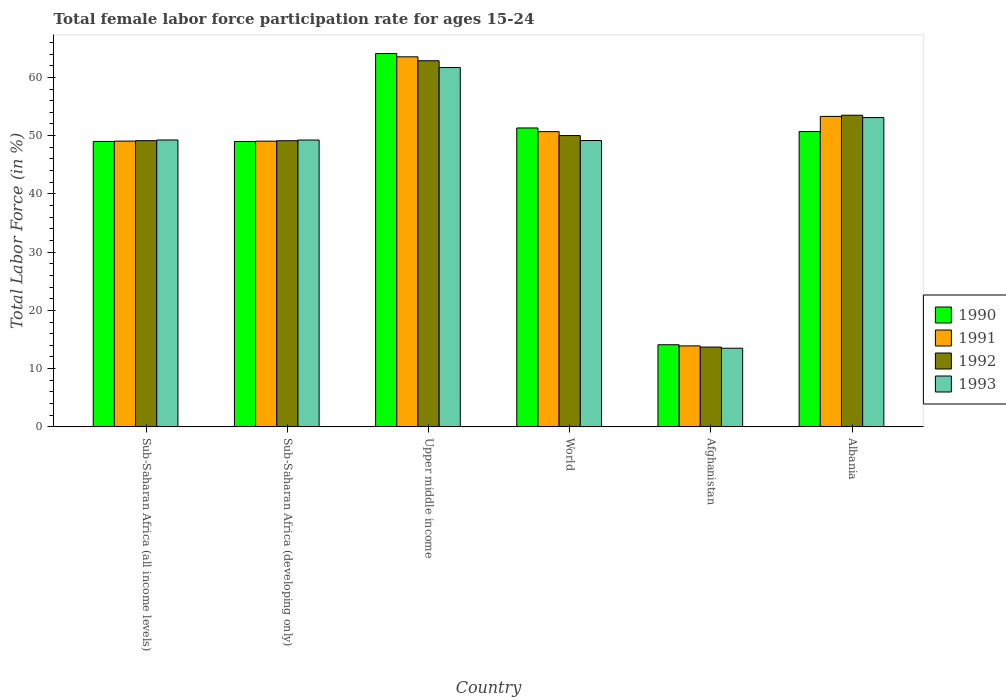How many groups of bars are there?
Provide a succinct answer. 6. Are the number of bars per tick equal to the number of legend labels?
Your answer should be very brief. Yes. How many bars are there on the 6th tick from the left?
Make the answer very short. 4. What is the label of the 6th group of bars from the left?
Your response must be concise. Albania. In how many cases, is the number of bars for a given country not equal to the number of legend labels?
Your answer should be very brief. 0. What is the female labor force participation rate in 1990 in World?
Offer a very short reply. 51.31. Across all countries, what is the maximum female labor force participation rate in 1991?
Offer a very short reply. 63.53. Across all countries, what is the minimum female labor force participation rate in 1992?
Offer a terse response. 13.7. In which country was the female labor force participation rate in 1991 maximum?
Offer a terse response. Upper middle income. In which country was the female labor force participation rate in 1993 minimum?
Make the answer very short. Afghanistan. What is the total female labor force participation rate in 1991 in the graph?
Give a very brief answer. 279.52. What is the difference between the female labor force participation rate in 1990 in Sub-Saharan Africa (developing only) and that in Upper middle income?
Give a very brief answer. -15.1. What is the difference between the female labor force participation rate in 1993 in Albania and the female labor force participation rate in 1990 in Afghanistan?
Ensure brevity in your answer.  39. What is the average female labor force participation rate in 1991 per country?
Offer a very short reply. 46.59. What is the difference between the female labor force participation rate of/in 1992 and female labor force participation rate of/in 1990 in Albania?
Ensure brevity in your answer.  2.8. In how many countries, is the female labor force participation rate in 1990 greater than 4 %?
Your answer should be very brief. 6. What is the ratio of the female labor force participation rate in 1993 in Afghanistan to that in Sub-Saharan Africa (all income levels)?
Keep it short and to the point. 0.27. Is the difference between the female labor force participation rate in 1992 in Afghanistan and Albania greater than the difference between the female labor force participation rate in 1990 in Afghanistan and Albania?
Your response must be concise. No. What is the difference between the highest and the second highest female labor force participation rate in 1992?
Provide a short and direct response. -3.49. What is the difference between the highest and the lowest female labor force participation rate in 1990?
Offer a terse response. 49.99. Is it the case that in every country, the sum of the female labor force participation rate in 1990 and female labor force participation rate in 1991 is greater than the sum of female labor force participation rate in 1993 and female labor force participation rate in 1992?
Make the answer very short. No. What does the 1st bar from the left in Afghanistan represents?
Offer a terse response. 1990. Is it the case that in every country, the sum of the female labor force participation rate in 1993 and female labor force participation rate in 1990 is greater than the female labor force participation rate in 1992?
Keep it short and to the point. Yes. How many bars are there?
Keep it short and to the point. 24. Are all the bars in the graph horizontal?
Offer a terse response. No. What is the difference between two consecutive major ticks on the Y-axis?
Provide a short and direct response. 10. Does the graph contain any zero values?
Keep it short and to the point. No. Does the graph contain grids?
Make the answer very short. No. Where does the legend appear in the graph?
Your answer should be very brief. Center right. How many legend labels are there?
Provide a succinct answer. 4. What is the title of the graph?
Offer a very short reply. Total female labor force participation rate for ages 15-24. What is the Total Labor Force (in %) of 1990 in Sub-Saharan Africa (all income levels)?
Ensure brevity in your answer.  49. What is the Total Labor Force (in %) of 1991 in Sub-Saharan Africa (all income levels)?
Keep it short and to the point. 49.06. What is the Total Labor Force (in %) of 1992 in Sub-Saharan Africa (all income levels)?
Provide a short and direct response. 49.13. What is the Total Labor Force (in %) in 1993 in Sub-Saharan Africa (all income levels)?
Offer a terse response. 49.25. What is the Total Labor Force (in %) of 1990 in Sub-Saharan Africa (developing only)?
Your answer should be compact. 48.99. What is the Total Labor Force (in %) of 1991 in Sub-Saharan Africa (developing only)?
Your answer should be compact. 49.05. What is the Total Labor Force (in %) in 1992 in Sub-Saharan Africa (developing only)?
Make the answer very short. 49.12. What is the Total Labor Force (in %) of 1993 in Sub-Saharan Africa (developing only)?
Make the answer very short. 49.24. What is the Total Labor Force (in %) in 1990 in Upper middle income?
Keep it short and to the point. 64.09. What is the Total Labor Force (in %) of 1991 in Upper middle income?
Provide a succinct answer. 63.53. What is the Total Labor Force (in %) of 1992 in Upper middle income?
Provide a succinct answer. 62.85. What is the Total Labor Force (in %) in 1993 in Upper middle income?
Give a very brief answer. 61.69. What is the Total Labor Force (in %) of 1990 in World?
Your answer should be compact. 51.31. What is the Total Labor Force (in %) in 1991 in World?
Give a very brief answer. 50.69. What is the Total Labor Force (in %) in 1992 in World?
Make the answer very short. 50.01. What is the Total Labor Force (in %) in 1993 in World?
Offer a very short reply. 49.16. What is the Total Labor Force (in %) in 1990 in Afghanistan?
Offer a very short reply. 14.1. What is the Total Labor Force (in %) in 1991 in Afghanistan?
Provide a succinct answer. 13.9. What is the Total Labor Force (in %) in 1992 in Afghanistan?
Give a very brief answer. 13.7. What is the Total Labor Force (in %) of 1993 in Afghanistan?
Your response must be concise. 13.5. What is the Total Labor Force (in %) of 1990 in Albania?
Your answer should be very brief. 50.7. What is the Total Labor Force (in %) in 1991 in Albania?
Offer a terse response. 53.3. What is the Total Labor Force (in %) of 1992 in Albania?
Your answer should be compact. 53.5. What is the Total Labor Force (in %) in 1993 in Albania?
Your answer should be compact. 53.1. Across all countries, what is the maximum Total Labor Force (in %) in 1990?
Offer a terse response. 64.09. Across all countries, what is the maximum Total Labor Force (in %) in 1991?
Provide a succinct answer. 63.53. Across all countries, what is the maximum Total Labor Force (in %) in 1992?
Your answer should be very brief. 62.85. Across all countries, what is the maximum Total Labor Force (in %) in 1993?
Provide a short and direct response. 61.69. Across all countries, what is the minimum Total Labor Force (in %) of 1990?
Offer a terse response. 14.1. Across all countries, what is the minimum Total Labor Force (in %) of 1991?
Provide a succinct answer. 13.9. Across all countries, what is the minimum Total Labor Force (in %) in 1992?
Your answer should be very brief. 13.7. What is the total Total Labor Force (in %) in 1990 in the graph?
Offer a very short reply. 278.2. What is the total Total Labor Force (in %) in 1991 in the graph?
Your answer should be very brief. 279.52. What is the total Total Labor Force (in %) in 1992 in the graph?
Your response must be concise. 278.31. What is the total Total Labor Force (in %) of 1993 in the graph?
Provide a succinct answer. 275.95. What is the difference between the Total Labor Force (in %) of 1990 in Sub-Saharan Africa (all income levels) and that in Sub-Saharan Africa (developing only)?
Your answer should be very brief. 0.01. What is the difference between the Total Labor Force (in %) in 1991 in Sub-Saharan Africa (all income levels) and that in Sub-Saharan Africa (developing only)?
Offer a very short reply. 0.01. What is the difference between the Total Labor Force (in %) of 1992 in Sub-Saharan Africa (all income levels) and that in Sub-Saharan Africa (developing only)?
Keep it short and to the point. 0.01. What is the difference between the Total Labor Force (in %) of 1993 in Sub-Saharan Africa (all income levels) and that in Sub-Saharan Africa (developing only)?
Provide a short and direct response. 0.01. What is the difference between the Total Labor Force (in %) of 1990 in Sub-Saharan Africa (all income levels) and that in Upper middle income?
Your response must be concise. -15.09. What is the difference between the Total Labor Force (in %) in 1991 in Sub-Saharan Africa (all income levels) and that in Upper middle income?
Give a very brief answer. -14.47. What is the difference between the Total Labor Force (in %) of 1992 in Sub-Saharan Africa (all income levels) and that in Upper middle income?
Offer a terse response. -13.72. What is the difference between the Total Labor Force (in %) in 1993 in Sub-Saharan Africa (all income levels) and that in Upper middle income?
Offer a very short reply. -12.44. What is the difference between the Total Labor Force (in %) of 1990 in Sub-Saharan Africa (all income levels) and that in World?
Your answer should be compact. -2.31. What is the difference between the Total Labor Force (in %) of 1991 in Sub-Saharan Africa (all income levels) and that in World?
Provide a succinct answer. -1.63. What is the difference between the Total Labor Force (in %) of 1992 in Sub-Saharan Africa (all income levels) and that in World?
Ensure brevity in your answer.  -0.87. What is the difference between the Total Labor Force (in %) in 1993 in Sub-Saharan Africa (all income levels) and that in World?
Offer a terse response. 0.09. What is the difference between the Total Labor Force (in %) in 1990 in Sub-Saharan Africa (all income levels) and that in Afghanistan?
Provide a short and direct response. 34.9. What is the difference between the Total Labor Force (in %) in 1991 in Sub-Saharan Africa (all income levels) and that in Afghanistan?
Keep it short and to the point. 35.16. What is the difference between the Total Labor Force (in %) in 1992 in Sub-Saharan Africa (all income levels) and that in Afghanistan?
Offer a terse response. 35.43. What is the difference between the Total Labor Force (in %) of 1993 in Sub-Saharan Africa (all income levels) and that in Afghanistan?
Keep it short and to the point. 35.75. What is the difference between the Total Labor Force (in %) of 1990 in Sub-Saharan Africa (all income levels) and that in Albania?
Provide a succinct answer. -1.7. What is the difference between the Total Labor Force (in %) of 1991 in Sub-Saharan Africa (all income levels) and that in Albania?
Provide a short and direct response. -4.24. What is the difference between the Total Labor Force (in %) in 1992 in Sub-Saharan Africa (all income levels) and that in Albania?
Ensure brevity in your answer.  -4.37. What is the difference between the Total Labor Force (in %) of 1993 in Sub-Saharan Africa (all income levels) and that in Albania?
Your answer should be compact. -3.85. What is the difference between the Total Labor Force (in %) in 1990 in Sub-Saharan Africa (developing only) and that in Upper middle income?
Offer a terse response. -15.1. What is the difference between the Total Labor Force (in %) in 1991 in Sub-Saharan Africa (developing only) and that in Upper middle income?
Offer a very short reply. -14.48. What is the difference between the Total Labor Force (in %) in 1992 in Sub-Saharan Africa (developing only) and that in Upper middle income?
Your answer should be very brief. -13.73. What is the difference between the Total Labor Force (in %) in 1993 in Sub-Saharan Africa (developing only) and that in Upper middle income?
Keep it short and to the point. -12.45. What is the difference between the Total Labor Force (in %) in 1990 in Sub-Saharan Africa (developing only) and that in World?
Provide a succinct answer. -2.32. What is the difference between the Total Labor Force (in %) of 1991 in Sub-Saharan Africa (developing only) and that in World?
Offer a terse response. -1.64. What is the difference between the Total Labor Force (in %) in 1992 in Sub-Saharan Africa (developing only) and that in World?
Ensure brevity in your answer.  -0.88. What is the difference between the Total Labor Force (in %) of 1993 in Sub-Saharan Africa (developing only) and that in World?
Make the answer very short. 0.08. What is the difference between the Total Labor Force (in %) in 1990 in Sub-Saharan Africa (developing only) and that in Afghanistan?
Give a very brief answer. 34.89. What is the difference between the Total Labor Force (in %) of 1991 in Sub-Saharan Africa (developing only) and that in Afghanistan?
Your response must be concise. 35.15. What is the difference between the Total Labor Force (in %) of 1992 in Sub-Saharan Africa (developing only) and that in Afghanistan?
Offer a very short reply. 35.42. What is the difference between the Total Labor Force (in %) in 1993 in Sub-Saharan Africa (developing only) and that in Afghanistan?
Provide a short and direct response. 35.74. What is the difference between the Total Labor Force (in %) of 1990 in Sub-Saharan Africa (developing only) and that in Albania?
Your answer should be very brief. -1.71. What is the difference between the Total Labor Force (in %) in 1991 in Sub-Saharan Africa (developing only) and that in Albania?
Keep it short and to the point. -4.25. What is the difference between the Total Labor Force (in %) in 1992 in Sub-Saharan Africa (developing only) and that in Albania?
Your answer should be compact. -4.38. What is the difference between the Total Labor Force (in %) in 1993 in Sub-Saharan Africa (developing only) and that in Albania?
Provide a short and direct response. -3.86. What is the difference between the Total Labor Force (in %) in 1990 in Upper middle income and that in World?
Ensure brevity in your answer.  12.78. What is the difference between the Total Labor Force (in %) of 1991 in Upper middle income and that in World?
Offer a very short reply. 12.84. What is the difference between the Total Labor Force (in %) in 1992 in Upper middle income and that in World?
Provide a succinct answer. 12.85. What is the difference between the Total Labor Force (in %) of 1993 in Upper middle income and that in World?
Offer a very short reply. 12.53. What is the difference between the Total Labor Force (in %) in 1990 in Upper middle income and that in Afghanistan?
Your answer should be very brief. 49.99. What is the difference between the Total Labor Force (in %) of 1991 in Upper middle income and that in Afghanistan?
Offer a terse response. 49.63. What is the difference between the Total Labor Force (in %) of 1992 in Upper middle income and that in Afghanistan?
Offer a very short reply. 49.15. What is the difference between the Total Labor Force (in %) of 1993 in Upper middle income and that in Afghanistan?
Your answer should be very brief. 48.19. What is the difference between the Total Labor Force (in %) in 1990 in Upper middle income and that in Albania?
Ensure brevity in your answer.  13.39. What is the difference between the Total Labor Force (in %) in 1991 in Upper middle income and that in Albania?
Keep it short and to the point. 10.23. What is the difference between the Total Labor Force (in %) of 1992 in Upper middle income and that in Albania?
Keep it short and to the point. 9.35. What is the difference between the Total Labor Force (in %) of 1993 in Upper middle income and that in Albania?
Make the answer very short. 8.59. What is the difference between the Total Labor Force (in %) of 1990 in World and that in Afghanistan?
Keep it short and to the point. 37.21. What is the difference between the Total Labor Force (in %) in 1991 in World and that in Afghanistan?
Ensure brevity in your answer.  36.79. What is the difference between the Total Labor Force (in %) in 1992 in World and that in Afghanistan?
Offer a terse response. 36.31. What is the difference between the Total Labor Force (in %) of 1993 in World and that in Afghanistan?
Ensure brevity in your answer.  35.66. What is the difference between the Total Labor Force (in %) of 1990 in World and that in Albania?
Offer a very short reply. 0.61. What is the difference between the Total Labor Force (in %) in 1991 in World and that in Albania?
Provide a succinct answer. -2.61. What is the difference between the Total Labor Force (in %) in 1992 in World and that in Albania?
Offer a very short reply. -3.49. What is the difference between the Total Labor Force (in %) in 1993 in World and that in Albania?
Offer a very short reply. -3.94. What is the difference between the Total Labor Force (in %) of 1990 in Afghanistan and that in Albania?
Your response must be concise. -36.6. What is the difference between the Total Labor Force (in %) in 1991 in Afghanistan and that in Albania?
Ensure brevity in your answer.  -39.4. What is the difference between the Total Labor Force (in %) in 1992 in Afghanistan and that in Albania?
Give a very brief answer. -39.8. What is the difference between the Total Labor Force (in %) in 1993 in Afghanistan and that in Albania?
Provide a succinct answer. -39.6. What is the difference between the Total Labor Force (in %) in 1990 in Sub-Saharan Africa (all income levels) and the Total Labor Force (in %) in 1991 in Sub-Saharan Africa (developing only)?
Keep it short and to the point. -0.05. What is the difference between the Total Labor Force (in %) in 1990 in Sub-Saharan Africa (all income levels) and the Total Labor Force (in %) in 1992 in Sub-Saharan Africa (developing only)?
Offer a very short reply. -0.12. What is the difference between the Total Labor Force (in %) in 1990 in Sub-Saharan Africa (all income levels) and the Total Labor Force (in %) in 1993 in Sub-Saharan Africa (developing only)?
Your answer should be very brief. -0.24. What is the difference between the Total Labor Force (in %) of 1991 in Sub-Saharan Africa (all income levels) and the Total Labor Force (in %) of 1992 in Sub-Saharan Africa (developing only)?
Make the answer very short. -0.06. What is the difference between the Total Labor Force (in %) in 1991 in Sub-Saharan Africa (all income levels) and the Total Labor Force (in %) in 1993 in Sub-Saharan Africa (developing only)?
Offer a terse response. -0.18. What is the difference between the Total Labor Force (in %) in 1992 in Sub-Saharan Africa (all income levels) and the Total Labor Force (in %) in 1993 in Sub-Saharan Africa (developing only)?
Your answer should be very brief. -0.11. What is the difference between the Total Labor Force (in %) of 1990 in Sub-Saharan Africa (all income levels) and the Total Labor Force (in %) of 1991 in Upper middle income?
Your response must be concise. -14.52. What is the difference between the Total Labor Force (in %) in 1990 in Sub-Saharan Africa (all income levels) and the Total Labor Force (in %) in 1992 in Upper middle income?
Your response must be concise. -13.85. What is the difference between the Total Labor Force (in %) in 1990 in Sub-Saharan Africa (all income levels) and the Total Labor Force (in %) in 1993 in Upper middle income?
Keep it short and to the point. -12.69. What is the difference between the Total Labor Force (in %) of 1991 in Sub-Saharan Africa (all income levels) and the Total Labor Force (in %) of 1992 in Upper middle income?
Make the answer very short. -13.79. What is the difference between the Total Labor Force (in %) in 1991 in Sub-Saharan Africa (all income levels) and the Total Labor Force (in %) in 1993 in Upper middle income?
Give a very brief answer. -12.63. What is the difference between the Total Labor Force (in %) in 1992 in Sub-Saharan Africa (all income levels) and the Total Labor Force (in %) in 1993 in Upper middle income?
Make the answer very short. -12.56. What is the difference between the Total Labor Force (in %) in 1990 in Sub-Saharan Africa (all income levels) and the Total Labor Force (in %) in 1991 in World?
Your response must be concise. -1.68. What is the difference between the Total Labor Force (in %) in 1990 in Sub-Saharan Africa (all income levels) and the Total Labor Force (in %) in 1992 in World?
Your answer should be very brief. -1. What is the difference between the Total Labor Force (in %) of 1990 in Sub-Saharan Africa (all income levels) and the Total Labor Force (in %) of 1993 in World?
Your answer should be compact. -0.16. What is the difference between the Total Labor Force (in %) of 1991 in Sub-Saharan Africa (all income levels) and the Total Labor Force (in %) of 1992 in World?
Your answer should be very brief. -0.95. What is the difference between the Total Labor Force (in %) of 1991 in Sub-Saharan Africa (all income levels) and the Total Labor Force (in %) of 1993 in World?
Your answer should be compact. -0.1. What is the difference between the Total Labor Force (in %) in 1992 in Sub-Saharan Africa (all income levels) and the Total Labor Force (in %) in 1993 in World?
Ensure brevity in your answer.  -0.03. What is the difference between the Total Labor Force (in %) in 1990 in Sub-Saharan Africa (all income levels) and the Total Labor Force (in %) in 1991 in Afghanistan?
Provide a succinct answer. 35.1. What is the difference between the Total Labor Force (in %) of 1990 in Sub-Saharan Africa (all income levels) and the Total Labor Force (in %) of 1992 in Afghanistan?
Offer a terse response. 35.3. What is the difference between the Total Labor Force (in %) in 1990 in Sub-Saharan Africa (all income levels) and the Total Labor Force (in %) in 1993 in Afghanistan?
Provide a succinct answer. 35.5. What is the difference between the Total Labor Force (in %) of 1991 in Sub-Saharan Africa (all income levels) and the Total Labor Force (in %) of 1992 in Afghanistan?
Make the answer very short. 35.36. What is the difference between the Total Labor Force (in %) in 1991 in Sub-Saharan Africa (all income levels) and the Total Labor Force (in %) in 1993 in Afghanistan?
Keep it short and to the point. 35.56. What is the difference between the Total Labor Force (in %) of 1992 in Sub-Saharan Africa (all income levels) and the Total Labor Force (in %) of 1993 in Afghanistan?
Provide a succinct answer. 35.63. What is the difference between the Total Labor Force (in %) in 1990 in Sub-Saharan Africa (all income levels) and the Total Labor Force (in %) in 1991 in Albania?
Offer a very short reply. -4.3. What is the difference between the Total Labor Force (in %) of 1990 in Sub-Saharan Africa (all income levels) and the Total Labor Force (in %) of 1992 in Albania?
Give a very brief answer. -4.5. What is the difference between the Total Labor Force (in %) in 1990 in Sub-Saharan Africa (all income levels) and the Total Labor Force (in %) in 1993 in Albania?
Give a very brief answer. -4.1. What is the difference between the Total Labor Force (in %) in 1991 in Sub-Saharan Africa (all income levels) and the Total Labor Force (in %) in 1992 in Albania?
Your response must be concise. -4.44. What is the difference between the Total Labor Force (in %) in 1991 in Sub-Saharan Africa (all income levels) and the Total Labor Force (in %) in 1993 in Albania?
Give a very brief answer. -4.04. What is the difference between the Total Labor Force (in %) in 1992 in Sub-Saharan Africa (all income levels) and the Total Labor Force (in %) in 1993 in Albania?
Your response must be concise. -3.97. What is the difference between the Total Labor Force (in %) in 1990 in Sub-Saharan Africa (developing only) and the Total Labor Force (in %) in 1991 in Upper middle income?
Your answer should be compact. -14.54. What is the difference between the Total Labor Force (in %) of 1990 in Sub-Saharan Africa (developing only) and the Total Labor Force (in %) of 1992 in Upper middle income?
Offer a very short reply. -13.86. What is the difference between the Total Labor Force (in %) in 1990 in Sub-Saharan Africa (developing only) and the Total Labor Force (in %) in 1993 in Upper middle income?
Offer a very short reply. -12.7. What is the difference between the Total Labor Force (in %) of 1991 in Sub-Saharan Africa (developing only) and the Total Labor Force (in %) of 1992 in Upper middle income?
Offer a very short reply. -13.81. What is the difference between the Total Labor Force (in %) of 1991 in Sub-Saharan Africa (developing only) and the Total Labor Force (in %) of 1993 in Upper middle income?
Make the answer very short. -12.64. What is the difference between the Total Labor Force (in %) in 1992 in Sub-Saharan Africa (developing only) and the Total Labor Force (in %) in 1993 in Upper middle income?
Provide a short and direct response. -12.57. What is the difference between the Total Labor Force (in %) of 1990 in Sub-Saharan Africa (developing only) and the Total Labor Force (in %) of 1991 in World?
Make the answer very short. -1.69. What is the difference between the Total Labor Force (in %) in 1990 in Sub-Saharan Africa (developing only) and the Total Labor Force (in %) in 1992 in World?
Your answer should be compact. -1.01. What is the difference between the Total Labor Force (in %) of 1990 in Sub-Saharan Africa (developing only) and the Total Labor Force (in %) of 1993 in World?
Provide a short and direct response. -0.17. What is the difference between the Total Labor Force (in %) in 1991 in Sub-Saharan Africa (developing only) and the Total Labor Force (in %) in 1992 in World?
Your answer should be compact. -0.96. What is the difference between the Total Labor Force (in %) of 1991 in Sub-Saharan Africa (developing only) and the Total Labor Force (in %) of 1993 in World?
Offer a terse response. -0.11. What is the difference between the Total Labor Force (in %) in 1992 in Sub-Saharan Africa (developing only) and the Total Labor Force (in %) in 1993 in World?
Offer a very short reply. -0.04. What is the difference between the Total Labor Force (in %) of 1990 in Sub-Saharan Africa (developing only) and the Total Labor Force (in %) of 1991 in Afghanistan?
Keep it short and to the point. 35.09. What is the difference between the Total Labor Force (in %) in 1990 in Sub-Saharan Africa (developing only) and the Total Labor Force (in %) in 1992 in Afghanistan?
Keep it short and to the point. 35.29. What is the difference between the Total Labor Force (in %) of 1990 in Sub-Saharan Africa (developing only) and the Total Labor Force (in %) of 1993 in Afghanistan?
Offer a terse response. 35.49. What is the difference between the Total Labor Force (in %) of 1991 in Sub-Saharan Africa (developing only) and the Total Labor Force (in %) of 1992 in Afghanistan?
Your answer should be compact. 35.35. What is the difference between the Total Labor Force (in %) of 1991 in Sub-Saharan Africa (developing only) and the Total Labor Force (in %) of 1993 in Afghanistan?
Keep it short and to the point. 35.55. What is the difference between the Total Labor Force (in %) in 1992 in Sub-Saharan Africa (developing only) and the Total Labor Force (in %) in 1993 in Afghanistan?
Your answer should be compact. 35.62. What is the difference between the Total Labor Force (in %) in 1990 in Sub-Saharan Africa (developing only) and the Total Labor Force (in %) in 1991 in Albania?
Provide a succinct answer. -4.31. What is the difference between the Total Labor Force (in %) in 1990 in Sub-Saharan Africa (developing only) and the Total Labor Force (in %) in 1992 in Albania?
Offer a terse response. -4.51. What is the difference between the Total Labor Force (in %) in 1990 in Sub-Saharan Africa (developing only) and the Total Labor Force (in %) in 1993 in Albania?
Keep it short and to the point. -4.11. What is the difference between the Total Labor Force (in %) in 1991 in Sub-Saharan Africa (developing only) and the Total Labor Force (in %) in 1992 in Albania?
Provide a short and direct response. -4.45. What is the difference between the Total Labor Force (in %) in 1991 in Sub-Saharan Africa (developing only) and the Total Labor Force (in %) in 1993 in Albania?
Offer a terse response. -4.05. What is the difference between the Total Labor Force (in %) in 1992 in Sub-Saharan Africa (developing only) and the Total Labor Force (in %) in 1993 in Albania?
Offer a very short reply. -3.98. What is the difference between the Total Labor Force (in %) of 1990 in Upper middle income and the Total Labor Force (in %) of 1991 in World?
Ensure brevity in your answer.  13.4. What is the difference between the Total Labor Force (in %) in 1990 in Upper middle income and the Total Labor Force (in %) in 1992 in World?
Ensure brevity in your answer.  14.08. What is the difference between the Total Labor Force (in %) in 1990 in Upper middle income and the Total Labor Force (in %) in 1993 in World?
Your response must be concise. 14.93. What is the difference between the Total Labor Force (in %) of 1991 in Upper middle income and the Total Labor Force (in %) of 1992 in World?
Offer a very short reply. 13.52. What is the difference between the Total Labor Force (in %) of 1991 in Upper middle income and the Total Labor Force (in %) of 1993 in World?
Your answer should be compact. 14.37. What is the difference between the Total Labor Force (in %) of 1992 in Upper middle income and the Total Labor Force (in %) of 1993 in World?
Offer a terse response. 13.69. What is the difference between the Total Labor Force (in %) in 1990 in Upper middle income and the Total Labor Force (in %) in 1991 in Afghanistan?
Offer a terse response. 50.19. What is the difference between the Total Labor Force (in %) in 1990 in Upper middle income and the Total Labor Force (in %) in 1992 in Afghanistan?
Offer a terse response. 50.39. What is the difference between the Total Labor Force (in %) in 1990 in Upper middle income and the Total Labor Force (in %) in 1993 in Afghanistan?
Your answer should be very brief. 50.59. What is the difference between the Total Labor Force (in %) in 1991 in Upper middle income and the Total Labor Force (in %) in 1992 in Afghanistan?
Provide a succinct answer. 49.83. What is the difference between the Total Labor Force (in %) of 1991 in Upper middle income and the Total Labor Force (in %) of 1993 in Afghanistan?
Offer a terse response. 50.03. What is the difference between the Total Labor Force (in %) in 1992 in Upper middle income and the Total Labor Force (in %) in 1993 in Afghanistan?
Your answer should be compact. 49.35. What is the difference between the Total Labor Force (in %) of 1990 in Upper middle income and the Total Labor Force (in %) of 1991 in Albania?
Keep it short and to the point. 10.79. What is the difference between the Total Labor Force (in %) in 1990 in Upper middle income and the Total Labor Force (in %) in 1992 in Albania?
Your answer should be very brief. 10.59. What is the difference between the Total Labor Force (in %) of 1990 in Upper middle income and the Total Labor Force (in %) of 1993 in Albania?
Ensure brevity in your answer.  10.99. What is the difference between the Total Labor Force (in %) in 1991 in Upper middle income and the Total Labor Force (in %) in 1992 in Albania?
Your answer should be compact. 10.03. What is the difference between the Total Labor Force (in %) in 1991 in Upper middle income and the Total Labor Force (in %) in 1993 in Albania?
Ensure brevity in your answer.  10.43. What is the difference between the Total Labor Force (in %) of 1992 in Upper middle income and the Total Labor Force (in %) of 1993 in Albania?
Make the answer very short. 9.75. What is the difference between the Total Labor Force (in %) in 1990 in World and the Total Labor Force (in %) in 1991 in Afghanistan?
Keep it short and to the point. 37.41. What is the difference between the Total Labor Force (in %) of 1990 in World and the Total Labor Force (in %) of 1992 in Afghanistan?
Give a very brief answer. 37.61. What is the difference between the Total Labor Force (in %) of 1990 in World and the Total Labor Force (in %) of 1993 in Afghanistan?
Keep it short and to the point. 37.81. What is the difference between the Total Labor Force (in %) of 1991 in World and the Total Labor Force (in %) of 1992 in Afghanistan?
Keep it short and to the point. 36.99. What is the difference between the Total Labor Force (in %) in 1991 in World and the Total Labor Force (in %) in 1993 in Afghanistan?
Offer a terse response. 37.19. What is the difference between the Total Labor Force (in %) in 1992 in World and the Total Labor Force (in %) in 1993 in Afghanistan?
Offer a very short reply. 36.51. What is the difference between the Total Labor Force (in %) in 1990 in World and the Total Labor Force (in %) in 1991 in Albania?
Offer a terse response. -1.99. What is the difference between the Total Labor Force (in %) in 1990 in World and the Total Labor Force (in %) in 1992 in Albania?
Offer a very short reply. -2.19. What is the difference between the Total Labor Force (in %) in 1990 in World and the Total Labor Force (in %) in 1993 in Albania?
Your answer should be compact. -1.79. What is the difference between the Total Labor Force (in %) of 1991 in World and the Total Labor Force (in %) of 1992 in Albania?
Provide a succinct answer. -2.81. What is the difference between the Total Labor Force (in %) in 1991 in World and the Total Labor Force (in %) in 1993 in Albania?
Provide a succinct answer. -2.41. What is the difference between the Total Labor Force (in %) in 1992 in World and the Total Labor Force (in %) in 1993 in Albania?
Offer a very short reply. -3.09. What is the difference between the Total Labor Force (in %) of 1990 in Afghanistan and the Total Labor Force (in %) of 1991 in Albania?
Provide a succinct answer. -39.2. What is the difference between the Total Labor Force (in %) of 1990 in Afghanistan and the Total Labor Force (in %) of 1992 in Albania?
Give a very brief answer. -39.4. What is the difference between the Total Labor Force (in %) in 1990 in Afghanistan and the Total Labor Force (in %) in 1993 in Albania?
Ensure brevity in your answer.  -39. What is the difference between the Total Labor Force (in %) in 1991 in Afghanistan and the Total Labor Force (in %) in 1992 in Albania?
Your response must be concise. -39.6. What is the difference between the Total Labor Force (in %) in 1991 in Afghanistan and the Total Labor Force (in %) in 1993 in Albania?
Keep it short and to the point. -39.2. What is the difference between the Total Labor Force (in %) of 1992 in Afghanistan and the Total Labor Force (in %) of 1993 in Albania?
Offer a very short reply. -39.4. What is the average Total Labor Force (in %) of 1990 per country?
Make the answer very short. 46.37. What is the average Total Labor Force (in %) in 1991 per country?
Provide a succinct answer. 46.59. What is the average Total Labor Force (in %) of 1992 per country?
Your response must be concise. 46.39. What is the average Total Labor Force (in %) of 1993 per country?
Your answer should be compact. 45.99. What is the difference between the Total Labor Force (in %) of 1990 and Total Labor Force (in %) of 1991 in Sub-Saharan Africa (all income levels)?
Offer a very short reply. -0.06. What is the difference between the Total Labor Force (in %) in 1990 and Total Labor Force (in %) in 1992 in Sub-Saharan Africa (all income levels)?
Offer a terse response. -0.13. What is the difference between the Total Labor Force (in %) in 1990 and Total Labor Force (in %) in 1993 in Sub-Saharan Africa (all income levels)?
Your answer should be compact. -0.25. What is the difference between the Total Labor Force (in %) in 1991 and Total Labor Force (in %) in 1992 in Sub-Saharan Africa (all income levels)?
Provide a short and direct response. -0.07. What is the difference between the Total Labor Force (in %) of 1991 and Total Labor Force (in %) of 1993 in Sub-Saharan Africa (all income levels)?
Provide a succinct answer. -0.19. What is the difference between the Total Labor Force (in %) in 1992 and Total Labor Force (in %) in 1993 in Sub-Saharan Africa (all income levels)?
Offer a very short reply. -0.12. What is the difference between the Total Labor Force (in %) of 1990 and Total Labor Force (in %) of 1991 in Sub-Saharan Africa (developing only)?
Offer a terse response. -0.06. What is the difference between the Total Labor Force (in %) of 1990 and Total Labor Force (in %) of 1992 in Sub-Saharan Africa (developing only)?
Your answer should be very brief. -0.13. What is the difference between the Total Labor Force (in %) in 1990 and Total Labor Force (in %) in 1993 in Sub-Saharan Africa (developing only)?
Keep it short and to the point. -0.25. What is the difference between the Total Labor Force (in %) in 1991 and Total Labor Force (in %) in 1992 in Sub-Saharan Africa (developing only)?
Make the answer very short. -0.07. What is the difference between the Total Labor Force (in %) of 1991 and Total Labor Force (in %) of 1993 in Sub-Saharan Africa (developing only)?
Keep it short and to the point. -0.2. What is the difference between the Total Labor Force (in %) of 1992 and Total Labor Force (in %) of 1993 in Sub-Saharan Africa (developing only)?
Your answer should be very brief. -0.12. What is the difference between the Total Labor Force (in %) in 1990 and Total Labor Force (in %) in 1991 in Upper middle income?
Make the answer very short. 0.56. What is the difference between the Total Labor Force (in %) in 1990 and Total Labor Force (in %) in 1992 in Upper middle income?
Ensure brevity in your answer.  1.24. What is the difference between the Total Labor Force (in %) in 1990 and Total Labor Force (in %) in 1993 in Upper middle income?
Keep it short and to the point. 2.4. What is the difference between the Total Labor Force (in %) of 1991 and Total Labor Force (in %) of 1992 in Upper middle income?
Your answer should be very brief. 0.67. What is the difference between the Total Labor Force (in %) in 1991 and Total Labor Force (in %) in 1993 in Upper middle income?
Your answer should be compact. 1.84. What is the difference between the Total Labor Force (in %) of 1992 and Total Labor Force (in %) of 1993 in Upper middle income?
Your response must be concise. 1.16. What is the difference between the Total Labor Force (in %) of 1990 and Total Labor Force (in %) of 1991 in World?
Keep it short and to the point. 0.63. What is the difference between the Total Labor Force (in %) in 1990 and Total Labor Force (in %) in 1992 in World?
Your answer should be compact. 1.31. What is the difference between the Total Labor Force (in %) of 1990 and Total Labor Force (in %) of 1993 in World?
Provide a short and direct response. 2.15. What is the difference between the Total Labor Force (in %) in 1991 and Total Labor Force (in %) in 1992 in World?
Ensure brevity in your answer.  0.68. What is the difference between the Total Labor Force (in %) of 1991 and Total Labor Force (in %) of 1993 in World?
Keep it short and to the point. 1.52. What is the difference between the Total Labor Force (in %) in 1992 and Total Labor Force (in %) in 1993 in World?
Provide a short and direct response. 0.84. What is the difference between the Total Labor Force (in %) in 1990 and Total Labor Force (in %) in 1992 in Afghanistan?
Your response must be concise. 0.4. What is the difference between the Total Labor Force (in %) of 1990 and Total Labor Force (in %) of 1993 in Afghanistan?
Your answer should be compact. 0.6. What is the difference between the Total Labor Force (in %) in 1991 and Total Labor Force (in %) in 1992 in Albania?
Provide a short and direct response. -0.2. What is the difference between the Total Labor Force (in %) of 1991 and Total Labor Force (in %) of 1993 in Albania?
Offer a very short reply. 0.2. What is the ratio of the Total Labor Force (in %) of 1991 in Sub-Saharan Africa (all income levels) to that in Sub-Saharan Africa (developing only)?
Your answer should be compact. 1. What is the ratio of the Total Labor Force (in %) in 1992 in Sub-Saharan Africa (all income levels) to that in Sub-Saharan Africa (developing only)?
Provide a short and direct response. 1. What is the ratio of the Total Labor Force (in %) in 1993 in Sub-Saharan Africa (all income levels) to that in Sub-Saharan Africa (developing only)?
Keep it short and to the point. 1. What is the ratio of the Total Labor Force (in %) in 1990 in Sub-Saharan Africa (all income levels) to that in Upper middle income?
Give a very brief answer. 0.76. What is the ratio of the Total Labor Force (in %) of 1991 in Sub-Saharan Africa (all income levels) to that in Upper middle income?
Your answer should be very brief. 0.77. What is the ratio of the Total Labor Force (in %) in 1992 in Sub-Saharan Africa (all income levels) to that in Upper middle income?
Give a very brief answer. 0.78. What is the ratio of the Total Labor Force (in %) in 1993 in Sub-Saharan Africa (all income levels) to that in Upper middle income?
Your answer should be very brief. 0.8. What is the ratio of the Total Labor Force (in %) in 1990 in Sub-Saharan Africa (all income levels) to that in World?
Give a very brief answer. 0.95. What is the ratio of the Total Labor Force (in %) of 1991 in Sub-Saharan Africa (all income levels) to that in World?
Provide a short and direct response. 0.97. What is the ratio of the Total Labor Force (in %) in 1992 in Sub-Saharan Africa (all income levels) to that in World?
Make the answer very short. 0.98. What is the ratio of the Total Labor Force (in %) in 1993 in Sub-Saharan Africa (all income levels) to that in World?
Give a very brief answer. 1. What is the ratio of the Total Labor Force (in %) in 1990 in Sub-Saharan Africa (all income levels) to that in Afghanistan?
Your response must be concise. 3.48. What is the ratio of the Total Labor Force (in %) in 1991 in Sub-Saharan Africa (all income levels) to that in Afghanistan?
Keep it short and to the point. 3.53. What is the ratio of the Total Labor Force (in %) of 1992 in Sub-Saharan Africa (all income levels) to that in Afghanistan?
Your answer should be very brief. 3.59. What is the ratio of the Total Labor Force (in %) in 1993 in Sub-Saharan Africa (all income levels) to that in Afghanistan?
Offer a very short reply. 3.65. What is the ratio of the Total Labor Force (in %) in 1990 in Sub-Saharan Africa (all income levels) to that in Albania?
Your response must be concise. 0.97. What is the ratio of the Total Labor Force (in %) in 1991 in Sub-Saharan Africa (all income levels) to that in Albania?
Your answer should be compact. 0.92. What is the ratio of the Total Labor Force (in %) in 1992 in Sub-Saharan Africa (all income levels) to that in Albania?
Your answer should be compact. 0.92. What is the ratio of the Total Labor Force (in %) in 1993 in Sub-Saharan Africa (all income levels) to that in Albania?
Make the answer very short. 0.93. What is the ratio of the Total Labor Force (in %) of 1990 in Sub-Saharan Africa (developing only) to that in Upper middle income?
Your answer should be very brief. 0.76. What is the ratio of the Total Labor Force (in %) in 1991 in Sub-Saharan Africa (developing only) to that in Upper middle income?
Provide a short and direct response. 0.77. What is the ratio of the Total Labor Force (in %) in 1992 in Sub-Saharan Africa (developing only) to that in Upper middle income?
Your answer should be very brief. 0.78. What is the ratio of the Total Labor Force (in %) in 1993 in Sub-Saharan Africa (developing only) to that in Upper middle income?
Give a very brief answer. 0.8. What is the ratio of the Total Labor Force (in %) of 1990 in Sub-Saharan Africa (developing only) to that in World?
Offer a very short reply. 0.95. What is the ratio of the Total Labor Force (in %) of 1991 in Sub-Saharan Africa (developing only) to that in World?
Ensure brevity in your answer.  0.97. What is the ratio of the Total Labor Force (in %) of 1992 in Sub-Saharan Africa (developing only) to that in World?
Offer a terse response. 0.98. What is the ratio of the Total Labor Force (in %) in 1993 in Sub-Saharan Africa (developing only) to that in World?
Give a very brief answer. 1. What is the ratio of the Total Labor Force (in %) in 1990 in Sub-Saharan Africa (developing only) to that in Afghanistan?
Ensure brevity in your answer.  3.47. What is the ratio of the Total Labor Force (in %) of 1991 in Sub-Saharan Africa (developing only) to that in Afghanistan?
Your answer should be compact. 3.53. What is the ratio of the Total Labor Force (in %) of 1992 in Sub-Saharan Africa (developing only) to that in Afghanistan?
Ensure brevity in your answer.  3.59. What is the ratio of the Total Labor Force (in %) in 1993 in Sub-Saharan Africa (developing only) to that in Afghanistan?
Ensure brevity in your answer.  3.65. What is the ratio of the Total Labor Force (in %) of 1990 in Sub-Saharan Africa (developing only) to that in Albania?
Your answer should be compact. 0.97. What is the ratio of the Total Labor Force (in %) of 1991 in Sub-Saharan Africa (developing only) to that in Albania?
Provide a succinct answer. 0.92. What is the ratio of the Total Labor Force (in %) in 1992 in Sub-Saharan Africa (developing only) to that in Albania?
Your response must be concise. 0.92. What is the ratio of the Total Labor Force (in %) of 1993 in Sub-Saharan Africa (developing only) to that in Albania?
Your answer should be very brief. 0.93. What is the ratio of the Total Labor Force (in %) in 1990 in Upper middle income to that in World?
Offer a terse response. 1.25. What is the ratio of the Total Labor Force (in %) in 1991 in Upper middle income to that in World?
Give a very brief answer. 1.25. What is the ratio of the Total Labor Force (in %) of 1992 in Upper middle income to that in World?
Your answer should be very brief. 1.26. What is the ratio of the Total Labor Force (in %) of 1993 in Upper middle income to that in World?
Your answer should be very brief. 1.25. What is the ratio of the Total Labor Force (in %) in 1990 in Upper middle income to that in Afghanistan?
Give a very brief answer. 4.55. What is the ratio of the Total Labor Force (in %) in 1991 in Upper middle income to that in Afghanistan?
Offer a very short reply. 4.57. What is the ratio of the Total Labor Force (in %) in 1992 in Upper middle income to that in Afghanistan?
Offer a terse response. 4.59. What is the ratio of the Total Labor Force (in %) of 1993 in Upper middle income to that in Afghanistan?
Provide a succinct answer. 4.57. What is the ratio of the Total Labor Force (in %) of 1990 in Upper middle income to that in Albania?
Offer a very short reply. 1.26. What is the ratio of the Total Labor Force (in %) in 1991 in Upper middle income to that in Albania?
Keep it short and to the point. 1.19. What is the ratio of the Total Labor Force (in %) in 1992 in Upper middle income to that in Albania?
Provide a succinct answer. 1.17. What is the ratio of the Total Labor Force (in %) in 1993 in Upper middle income to that in Albania?
Your response must be concise. 1.16. What is the ratio of the Total Labor Force (in %) in 1990 in World to that in Afghanistan?
Ensure brevity in your answer.  3.64. What is the ratio of the Total Labor Force (in %) in 1991 in World to that in Afghanistan?
Give a very brief answer. 3.65. What is the ratio of the Total Labor Force (in %) of 1992 in World to that in Afghanistan?
Your response must be concise. 3.65. What is the ratio of the Total Labor Force (in %) in 1993 in World to that in Afghanistan?
Keep it short and to the point. 3.64. What is the ratio of the Total Labor Force (in %) of 1990 in World to that in Albania?
Your answer should be compact. 1.01. What is the ratio of the Total Labor Force (in %) in 1991 in World to that in Albania?
Provide a succinct answer. 0.95. What is the ratio of the Total Labor Force (in %) in 1992 in World to that in Albania?
Offer a very short reply. 0.93. What is the ratio of the Total Labor Force (in %) in 1993 in World to that in Albania?
Offer a very short reply. 0.93. What is the ratio of the Total Labor Force (in %) in 1990 in Afghanistan to that in Albania?
Offer a very short reply. 0.28. What is the ratio of the Total Labor Force (in %) of 1991 in Afghanistan to that in Albania?
Make the answer very short. 0.26. What is the ratio of the Total Labor Force (in %) in 1992 in Afghanistan to that in Albania?
Ensure brevity in your answer.  0.26. What is the ratio of the Total Labor Force (in %) of 1993 in Afghanistan to that in Albania?
Your answer should be compact. 0.25. What is the difference between the highest and the second highest Total Labor Force (in %) in 1990?
Your answer should be compact. 12.78. What is the difference between the highest and the second highest Total Labor Force (in %) in 1991?
Provide a short and direct response. 10.23. What is the difference between the highest and the second highest Total Labor Force (in %) in 1992?
Offer a very short reply. 9.35. What is the difference between the highest and the second highest Total Labor Force (in %) of 1993?
Ensure brevity in your answer.  8.59. What is the difference between the highest and the lowest Total Labor Force (in %) in 1990?
Offer a terse response. 49.99. What is the difference between the highest and the lowest Total Labor Force (in %) in 1991?
Provide a short and direct response. 49.63. What is the difference between the highest and the lowest Total Labor Force (in %) in 1992?
Your answer should be very brief. 49.15. What is the difference between the highest and the lowest Total Labor Force (in %) of 1993?
Keep it short and to the point. 48.19. 